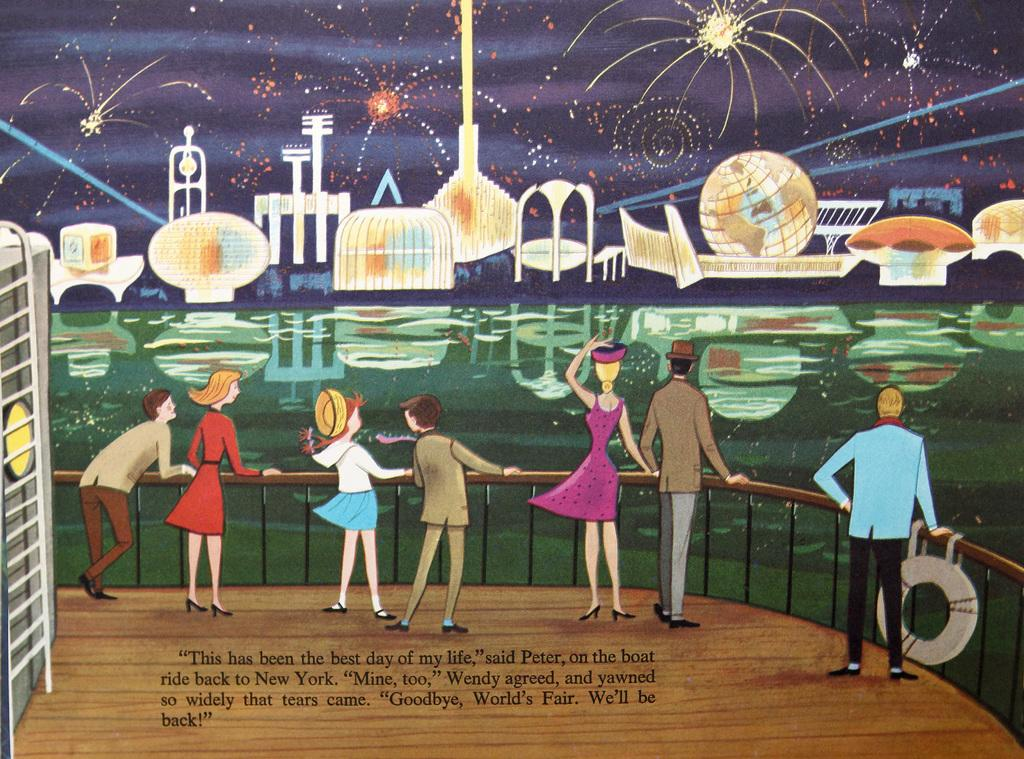What style is the image drawn in? The image is a cartoon. What else can be found in the image besides the visual elements? There is text present in the image. How many cats are sitting on the calendar in the image? There are no cats or calendars present in the image; it is a cartoon with text. 